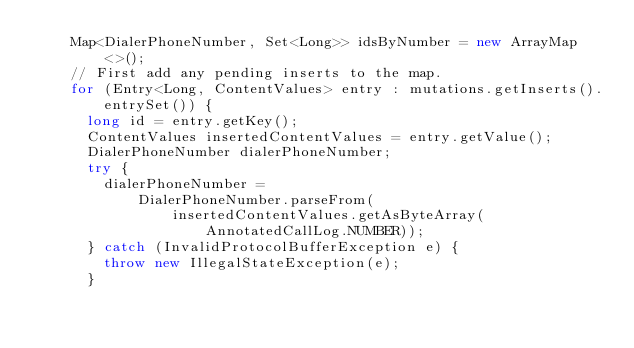<code> <loc_0><loc_0><loc_500><loc_500><_Java_>    Map<DialerPhoneNumber, Set<Long>> idsByNumber = new ArrayMap<>();
    // First add any pending inserts to the map.
    for (Entry<Long, ContentValues> entry : mutations.getInserts().entrySet()) {
      long id = entry.getKey();
      ContentValues insertedContentValues = entry.getValue();
      DialerPhoneNumber dialerPhoneNumber;
      try {
        dialerPhoneNumber =
            DialerPhoneNumber.parseFrom(
                insertedContentValues.getAsByteArray(AnnotatedCallLog.NUMBER));
      } catch (InvalidProtocolBufferException e) {
        throw new IllegalStateException(e);
      }</code> 